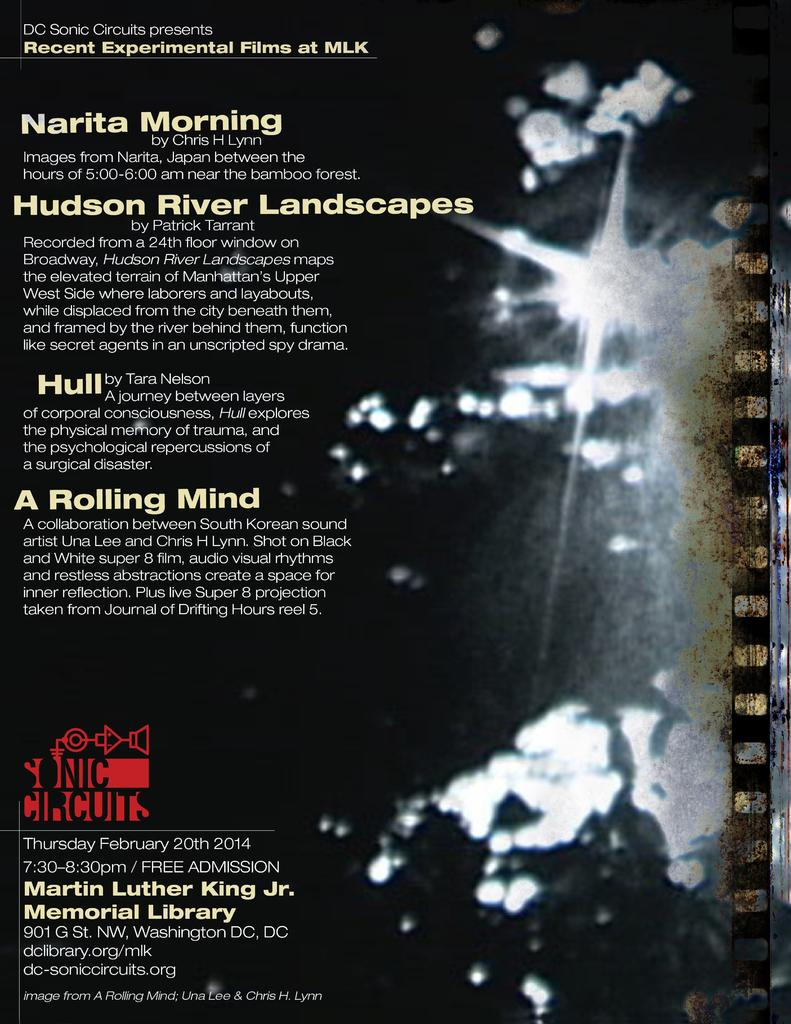<image>
Give a short and clear explanation of the subsequent image. poster for recent experimental films at the martin luther king jr memorial library 